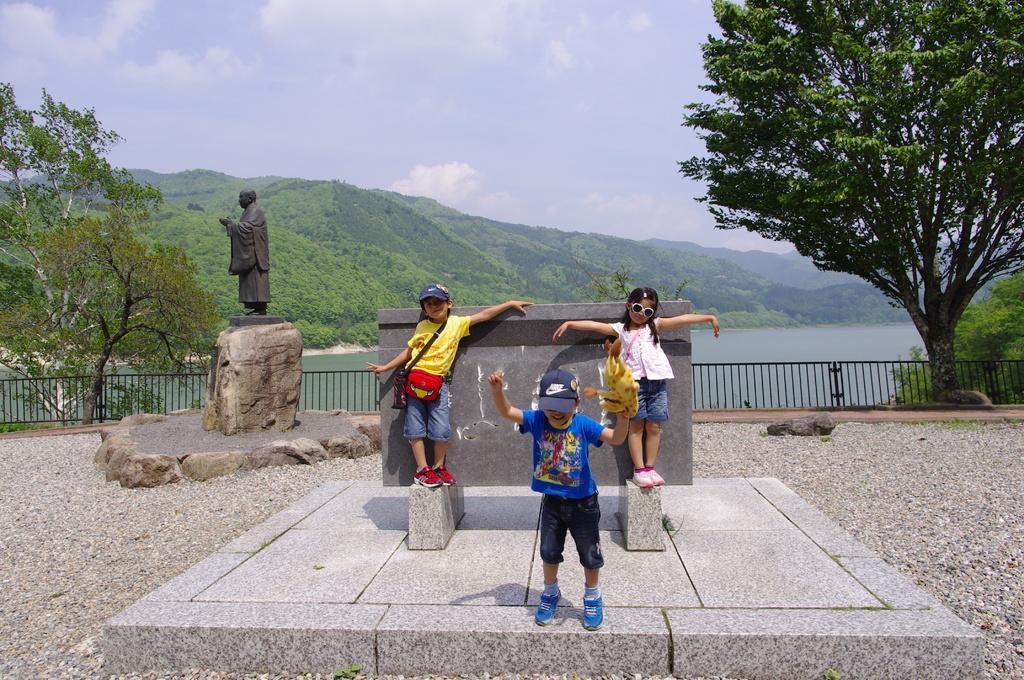Can you describe this image briefly? In this image I can see few children are standing in the front. In the background I can see railing, few trees, water, clouds, the sky and a black colour sculpture. 